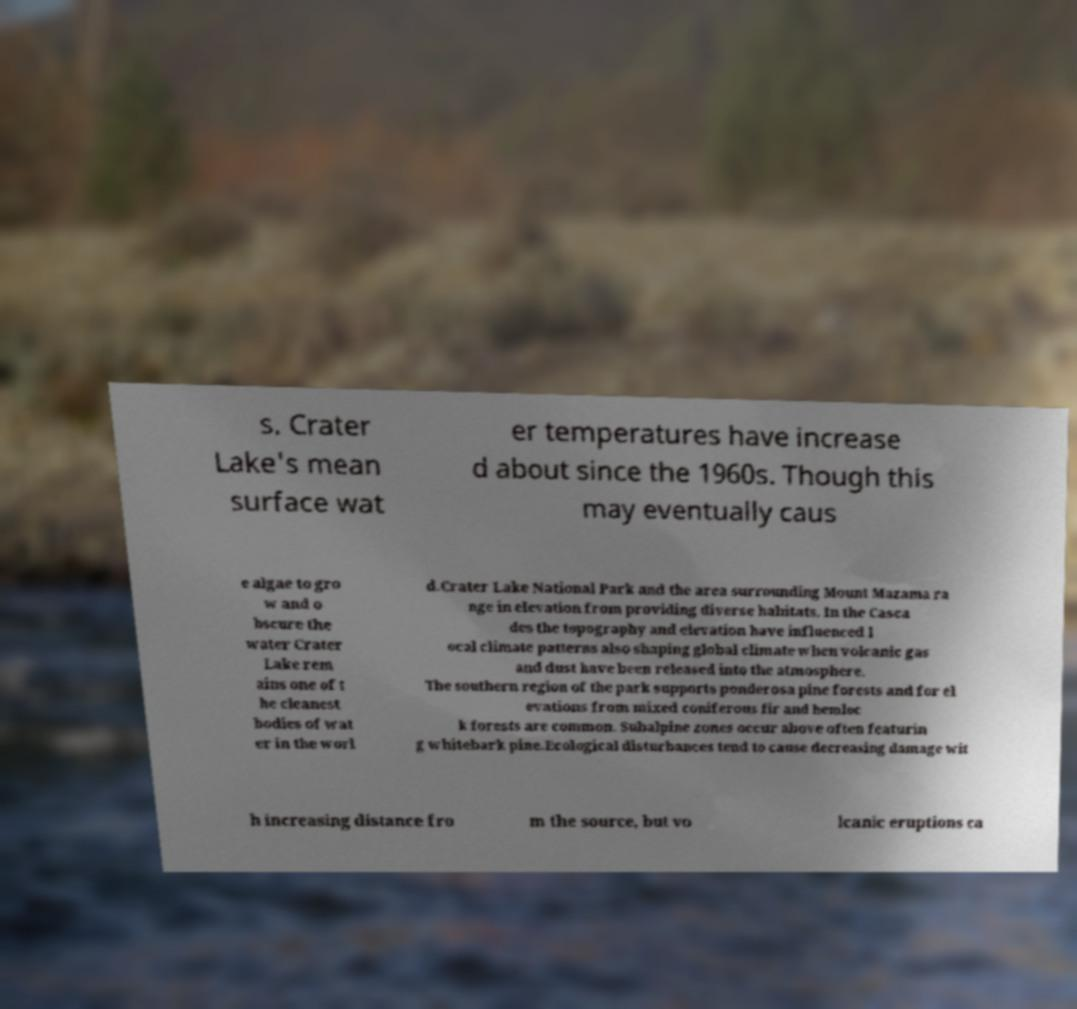Could you extract and type out the text from this image? s. Crater Lake's mean surface wat er temperatures have increase d about since the 1960s. Though this may eventually caus e algae to gro w and o bscure the water Crater Lake rem ains one of t he cleanest bodies of wat er in the worl d.Crater Lake National Park and the area surrounding Mount Mazama ra nge in elevation from providing diverse habitats. In the Casca des the topography and elevation have influenced l ocal climate patterns also shaping global climate when volcanic gas and dust have been released into the atmosphere. The southern region of the park supports ponderosa pine forests and for el evations from mixed coniferous fir and hemloc k forests are common. Subalpine zones occur above often featurin g whitebark pine.Ecological disturbances tend to cause decreasing damage wit h increasing distance fro m the source, but vo lcanic eruptions ca 